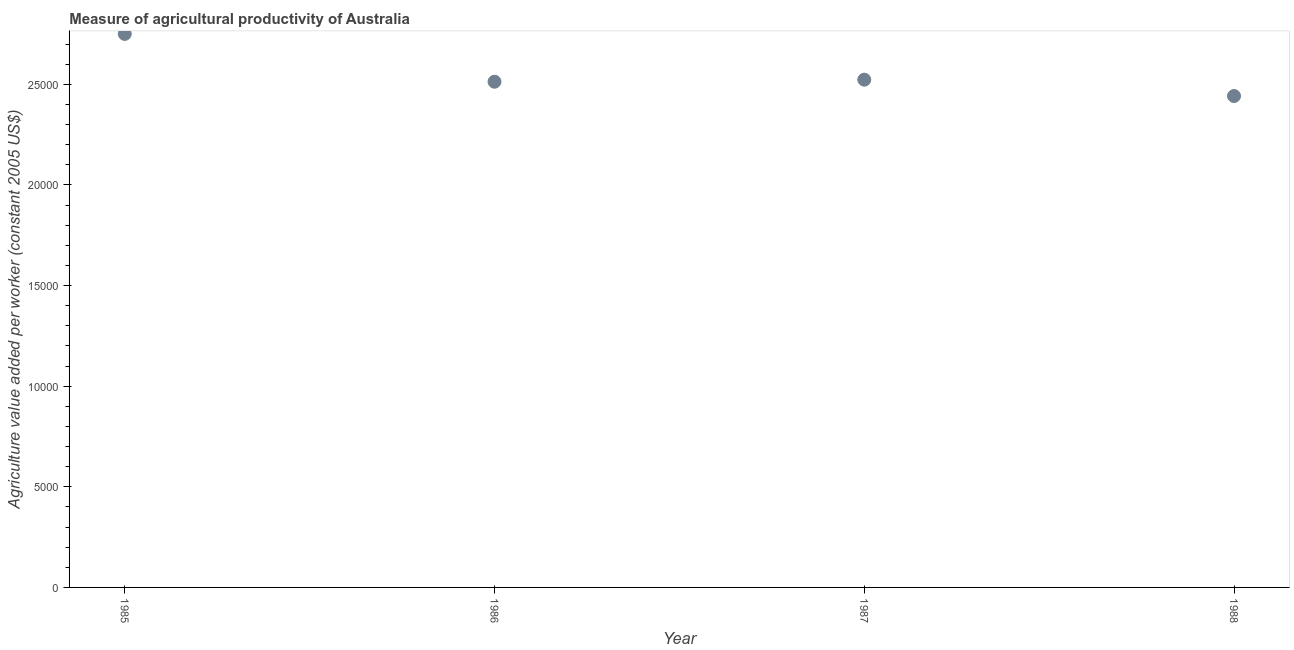What is the agriculture value added per worker in 1985?
Offer a terse response. 2.75e+04. Across all years, what is the maximum agriculture value added per worker?
Keep it short and to the point. 2.75e+04. Across all years, what is the minimum agriculture value added per worker?
Give a very brief answer. 2.44e+04. In which year was the agriculture value added per worker maximum?
Give a very brief answer. 1985. What is the sum of the agriculture value added per worker?
Give a very brief answer. 1.02e+05. What is the difference between the agriculture value added per worker in 1986 and 1987?
Give a very brief answer. -101.86. What is the average agriculture value added per worker per year?
Offer a very short reply. 2.56e+04. What is the median agriculture value added per worker?
Your answer should be compact. 2.52e+04. In how many years, is the agriculture value added per worker greater than 25000 US$?
Your answer should be very brief. 3. Do a majority of the years between 1987 and 1988 (inclusive) have agriculture value added per worker greater than 9000 US$?
Ensure brevity in your answer.  Yes. What is the ratio of the agriculture value added per worker in 1986 to that in 1987?
Provide a succinct answer. 1. Is the agriculture value added per worker in 1986 less than that in 1987?
Offer a terse response. Yes. What is the difference between the highest and the second highest agriculture value added per worker?
Offer a very short reply. 2272.86. Is the sum of the agriculture value added per worker in 1985 and 1987 greater than the maximum agriculture value added per worker across all years?
Provide a succinct answer. Yes. What is the difference between the highest and the lowest agriculture value added per worker?
Keep it short and to the point. 3084.77. Does the agriculture value added per worker monotonically increase over the years?
Keep it short and to the point. No. How many dotlines are there?
Give a very brief answer. 1. Are the values on the major ticks of Y-axis written in scientific E-notation?
Offer a very short reply. No. What is the title of the graph?
Offer a very short reply. Measure of agricultural productivity of Australia. What is the label or title of the Y-axis?
Your answer should be very brief. Agriculture value added per worker (constant 2005 US$). What is the Agriculture value added per worker (constant 2005 US$) in 1985?
Your response must be concise. 2.75e+04. What is the Agriculture value added per worker (constant 2005 US$) in 1986?
Provide a succinct answer. 2.51e+04. What is the Agriculture value added per worker (constant 2005 US$) in 1987?
Your answer should be compact. 2.52e+04. What is the Agriculture value added per worker (constant 2005 US$) in 1988?
Offer a terse response. 2.44e+04. What is the difference between the Agriculture value added per worker (constant 2005 US$) in 1985 and 1986?
Provide a succinct answer. 2374.72. What is the difference between the Agriculture value added per worker (constant 2005 US$) in 1985 and 1987?
Provide a succinct answer. 2272.86. What is the difference between the Agriculture value added per worker (constant 2005 US$) in 1985 and 1988?
Ensure brevity in your answer.  3084.77. What is the difference between the Agriculture value added per worker (constant 2005 US$) in 1986 and 1987?
Keep it short and to the point. -101.86. What is the difference between the Agriculture value added per worker (constant 2005 US$) in 1986 and 1988?
Offer a very short reply. 710.05. What is the difference between the Agriculture value added per worker (constant 2005 US$) in 1987 and 1988?
Your response must be concise. 811.9. What is the ratio of the Agriculture value added per worker (constant 2005 US$) in 1985 to that in 1986?
Offer a terse response. 1.09. What is the ratio of the Agriculture value added per worker (constant 2005 US$) in 1985 to that in 1987?
Provide a succinct answer. 1.09. What is the ratio of the Agriculture value added per worker (constant 2005 US$) in 1985 to that in 1988?
Your answer should be compact. 1.13. What is the ratio of the Agriculture value added per worker (constant 2005 US$) in 1986 to that in 1987?
Ensure brevity in your answer.  1. What is the ratio of the Agriculture value added per worker (constant 2005 US$) in 1987 to that in 1988?
Give a very brief answer. 1.03. 